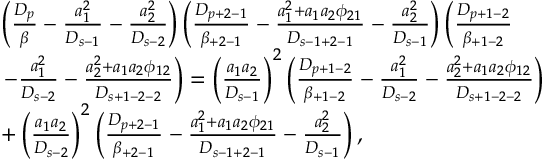Convert formula to latex. <formula><loc_0><loc_0><loc_500><loc_500>\begin{array} { r l } & { \left ( \frac { D _ { p } } { \beta } - \frac { a _ { 1 } ^ { 2 } } { D _ { s - 1 } } - \frac { a _ { 2 } ^ { 2 } } { D _ { s - 2 } } \right ) \left ( \frac { D _ { p + 2 - 1 } } { \beta _ { + 2 - 1 } } - \frac { a _ { 1 } ^ { 2 } + a _ { 1 } a _ { 2 } \phi _ { 2 1 } } { D _ { s - 1 + 2 - 1 } } - \frac { a _ { 2 } ^ { 2 } } { D _ { s - 1 } } \right ) \left ( \frac { D _ { p + 1 - 2 } } { \beta _ { + 1 - 2 } } } \\ & { - \frac { a _ { 1 } ^ { 2 } } { D _ { s - 2 } } - \frac { a _ { 2 } ^ { 2 } + a _ { 1 } a _ { 2 } \phi _ { 1 2 } } { D _ { s + 1 - 2 - 2 } } \right ) = \left ( \frac { a _ { 1 } a _ { 2 } } { D _ { s - 1 } } \right ) ^ { 2 } \left ( \frac { D _ { p + 1 - 2 } } { \beta _ { + 1 - 2 } } - \frac { a _ { 1 } ^ { 2 } } { D _ { s - 2 } } - \frac { a _ { 2 } ^ { 2 } + a _ { 1 } a _ { 2 } \phi _ { 1 2 } } { D _ { s + 1 - 2 - 2 } } \right ) } \\ & { + \left ( \frac { a _ { 1 } a _ { 2 } } { D _ { s - 2 } } \right ) ^ { 2 } \left ( \frac { D _ { p + 2 - 1 } } { \beta _ { + 2 - 1 } } - \frac { a _ { 1 } ^ { 2 } + a _ { 1 } a _ { 2 } \phi _ { 2 1 } } { D _ { s - 1 + 2 - 1 } } - \frac { a _ { 2 } ^ { 2 } } { D _ { s - 1 } } \right ) , } \end{array}</formula> 